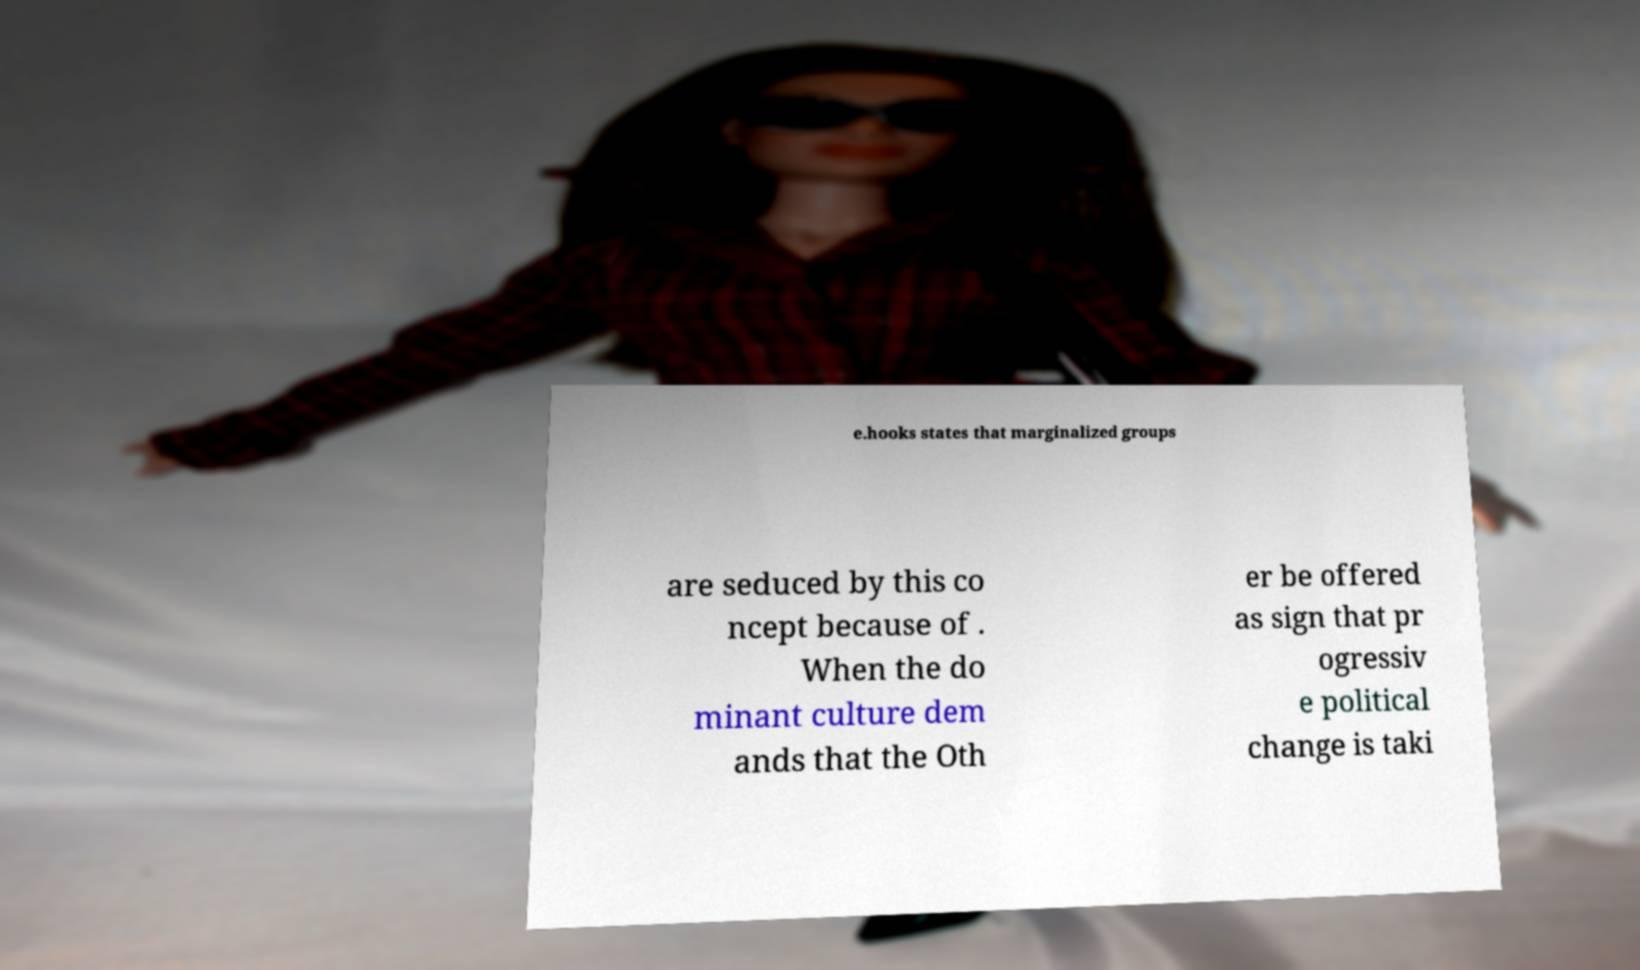Could you extract and type out the text from this image? e.hooks states that marginalized groups are seduced by this co ncept because of . When the do minant culture dem ands that the Oth er be offered as sign that pr ogressiv e political change is taki 